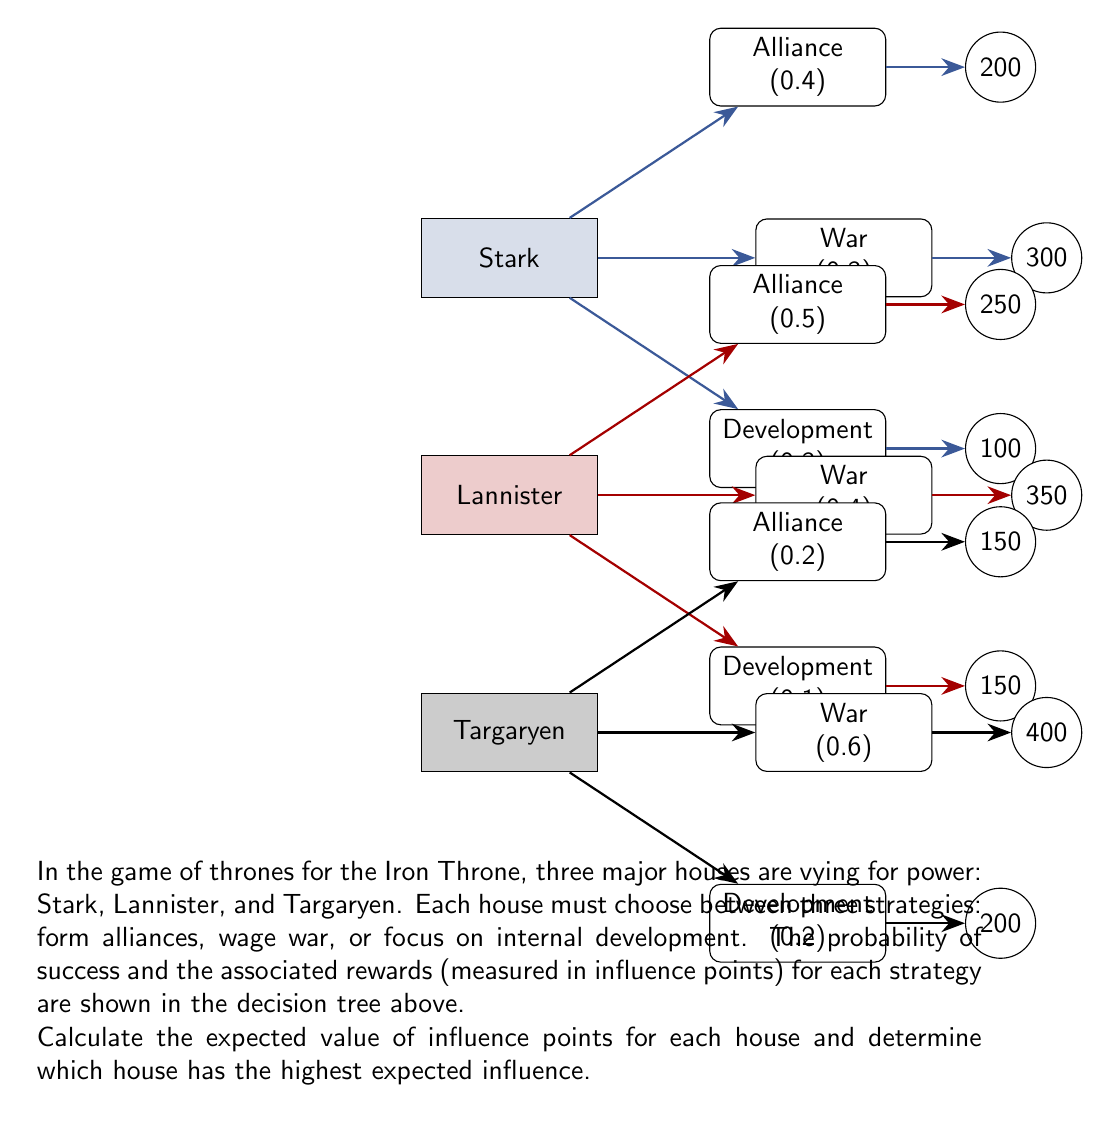Provide a solution to this math problem. To solve this problem, we need to calculate the expected value for each house using the given probabilities and rewards. The expected value is the sum of each outcome multiplied by its probability.

1. For House Stark:
   $$E(\text{Stark}) = (0.4 \times 200) + (0.3 \times 300) + (0.3 \times 100)$$
   $$E(\text{Stark}) = 80 + 90 + 30 = 200$$

2. For House Lannister:
   $$E(\text{Lannister}) = (0.5 \times 250) + (0.4 \times 350) + (0.1 \times 150)$$
   $$E(\text{Lannister}) = 125 + 140 + 15 = 280$$

3. For House Targaryen:
   $$E(\text{Targaryen}) = (0.2 \times 150) + (0.6 \times 400) + (0.2 \times 200)$$
   $$E(\text{Targaryen}) = 30 + 240 + 40 = 310$$

Now, we compare the expected values:
   House Stark: 200
   House Lannister: 280
   House Targaryen: 310

House Targaryen has the highest expected influence with 310 points.
Answer: House Targaryen, 310 influence points 